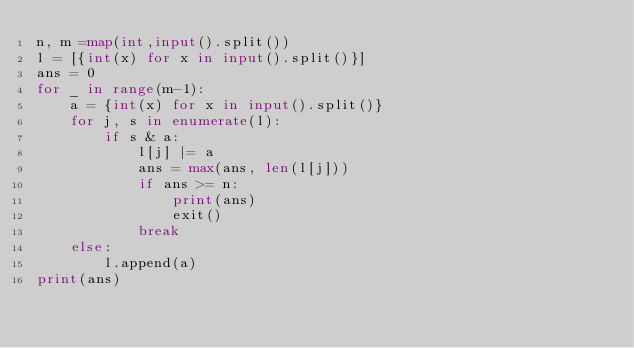<code> <loc_0><loc_0><loc_500><loc_500><_Python_>n, m =map(int,input().split())
l = [{int(x) for x in input().split()}]
ans = 0
for _ in range(m-1):
    a = {int(x) for x in input().split()}
    for j, s in enumerate(l):
        if s & a:
            l[j] |= a
            ans = max(ans, len(l[j]))
            if ans >= n:
                print(ans)
                exit()
            break
    else:
        l.append(a)
print(ans)
</code> 